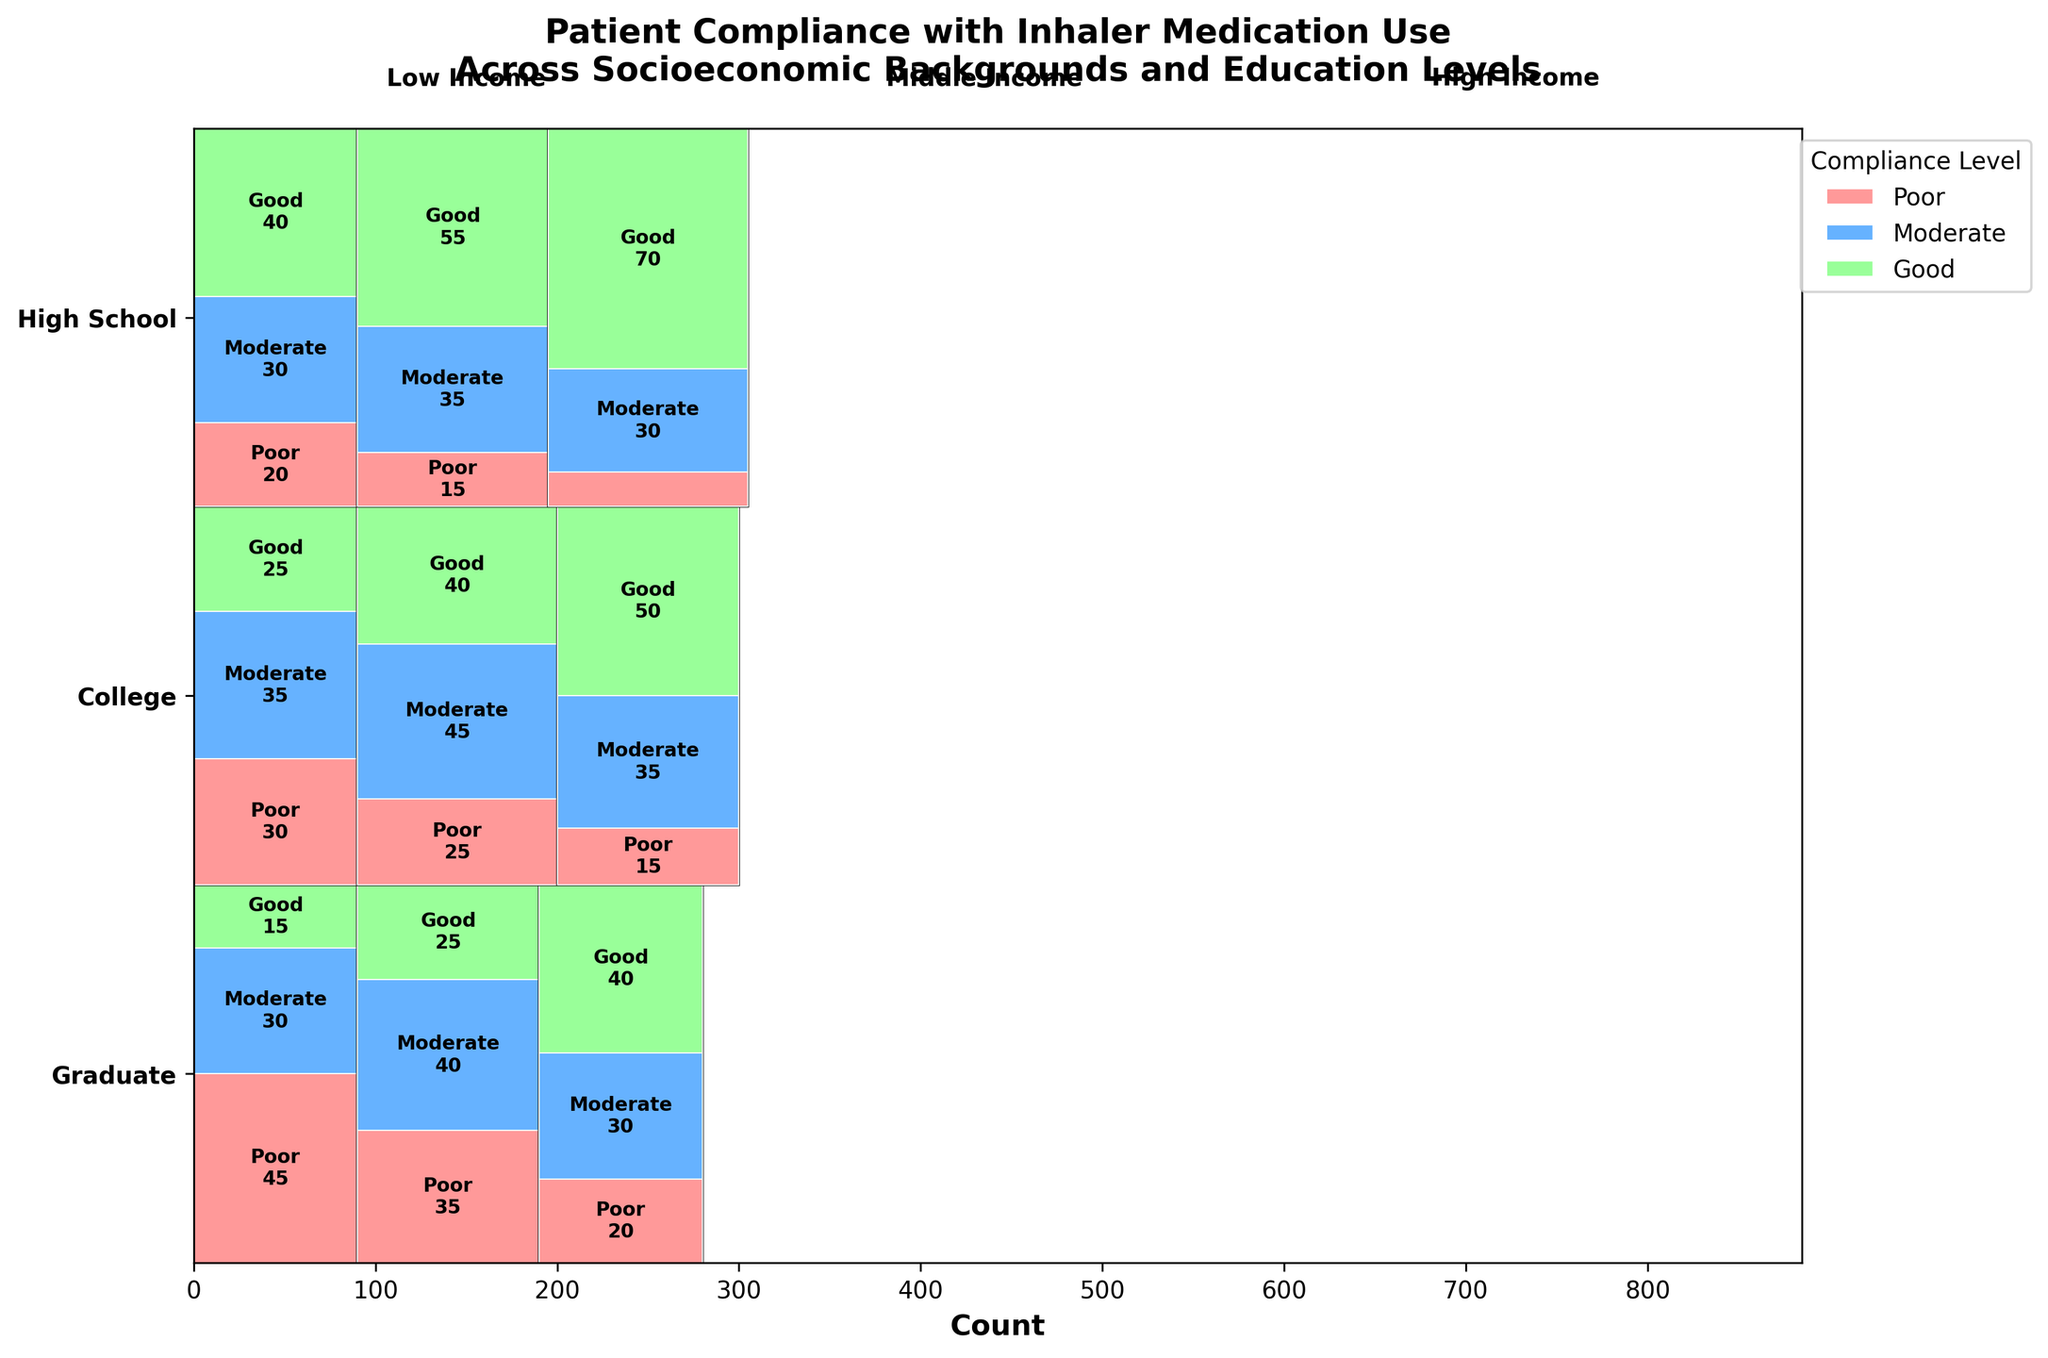What is the title of the figure? The title is written at the top of the figure, and it summarizes the main focus of the visualized data.
Answer: Patient Compliance with Inhaler Medication Use Across Socioeconomic Backgrounds and Education Levels How many compliance levels are shown in the figure? There are distinct colors representing each compliance level within the rectangular sections of the mosaic plot. By looking at the legend, one can count the number of compliance levels depicted.
Answer: Three (Poor, Moderate, Good) Which socioeconomic status shows the highest overall compliance for patients with a Graduate education level? By observing the Graduate category on the y-axis and comparing the sizes of each compliance level rectangle within different socioeconomic statuses, the socioeconomic status with the largest 'Good' compliance rectangle will be evident.
Answer: High Income In which socioeconomic status and education level is 'Poor' compliance the lowest? By scanning through all rectangles labeled 'Poor' across different education levels and socioeconomic statuses, the smallest rectangle can be identified since this represents the lowest count.
Answer: Graduate, High Income Which socioeconomic group has the most balanced compliance levels (largest proportion of each compliance level being relatively equal) for Graduate education? Examine the relative sizes of 'Poor', 'Moderate', and 'Good' compliance rectangles for Graduate education across socioeconomic groups and identify the most balanced one.
Answer: Low Income Which socioeconomic status for Low Income has the fewest total patients across all compliance levels? Add up the total counts of 'Poor', 'Moderate', and 'Good' compliance levels for each socioeconomic status within the Low Income category, comparing the sums.
Answer: High School (45+30+15 = 90) 